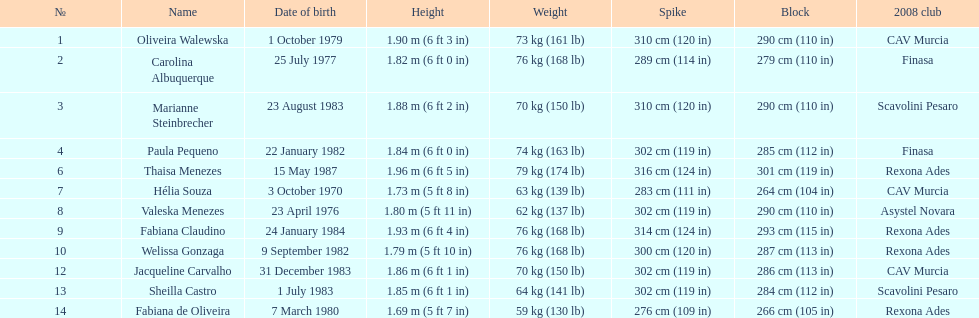Out of fabiana de oliveira, helia souza, and sheilla castro, who has the greatest weight? Sheilla Castro. 